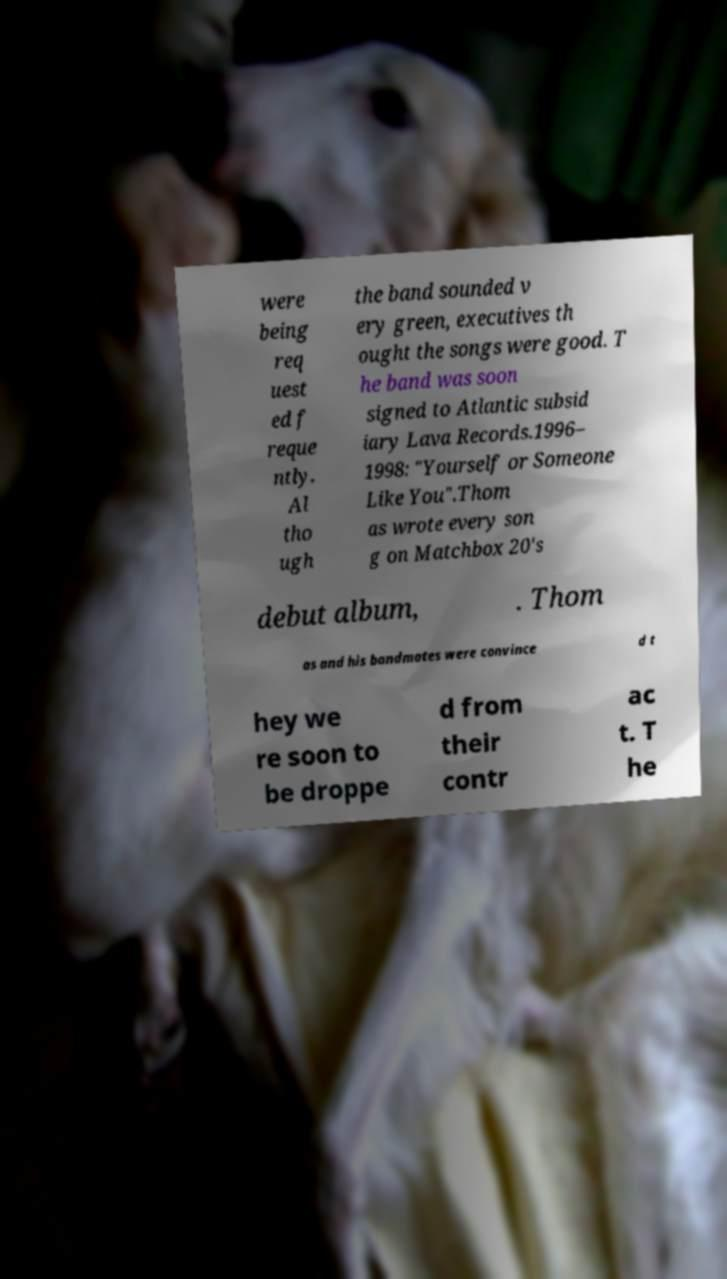Please read and relay the text visible in this image. What does it say? were being req uest ed f reque ntly. Al tho ugh the band sounded v ery green, executives th ought the songs were good. T he band was soon signed to Atlantic subsid iary Lava Records.1996– 1998: "Yourself or Someone Like You".Thom as wrote every son g on Matchbox 20's debut album, . Thom as and his bandmates were convince d t hey we re soon to be droppe d from their contr ac t. T he 